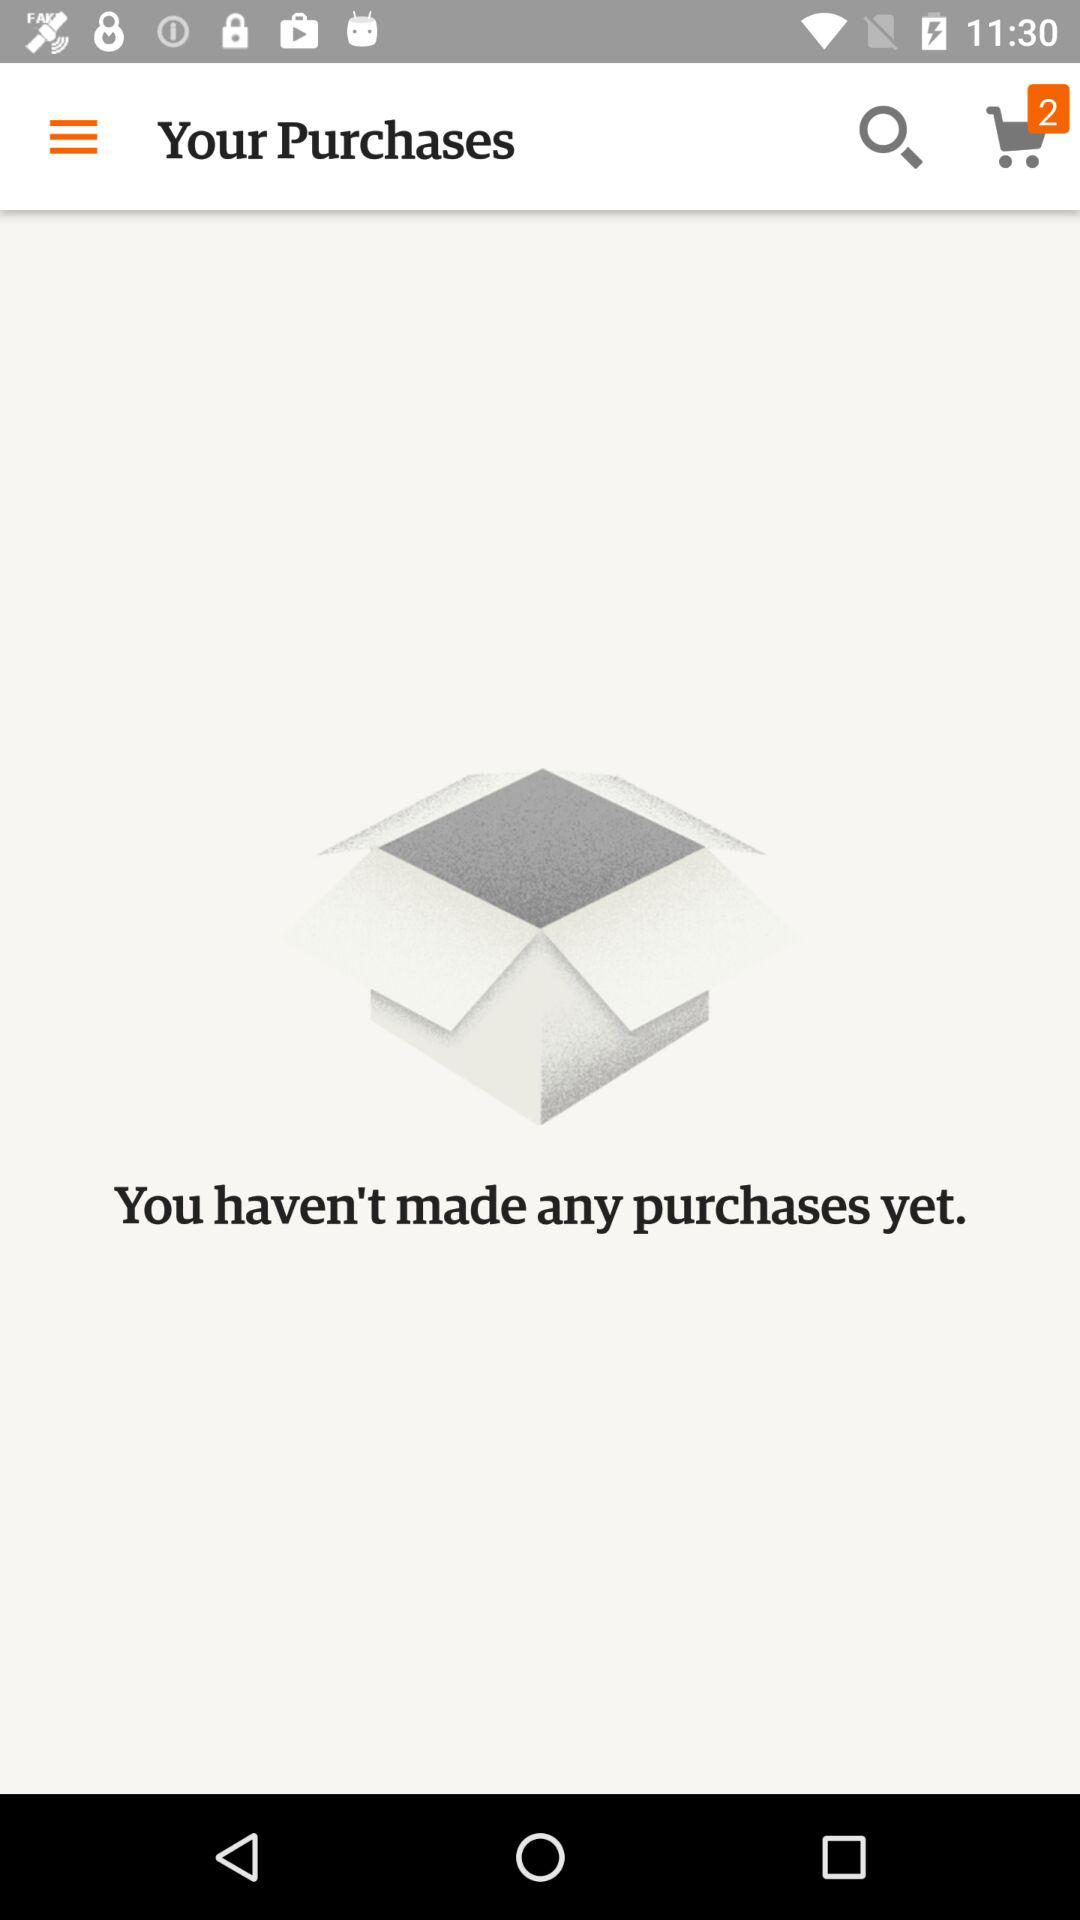How much is the total of the purchases?
When the provided information is insufficient, respond with <no answer>. <no answer> 